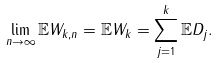Convert formula to latex. <formula><loc_0><loc_0><loc_500><loc_500>\lim _ { n \to \infty } \mathbb { E } W _ { k , n } = \mathbb { E } W _ { k } = \sum _ { j = 1 } ^ { k } \mathbb { E } D _ { j } .</formula> 